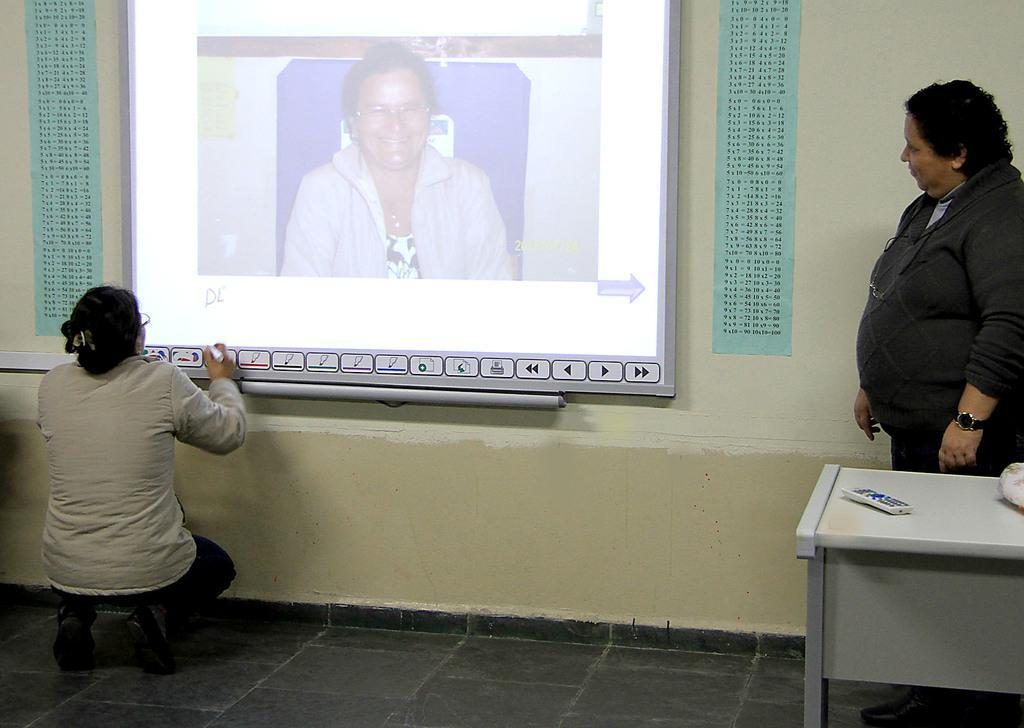Please provide a concise description of this image. In this picture we can see a person is standing on the floor and a in front of the person there is a table and on the table there is a remote control. On the left side of the person there is another person is in squat position and in front of the person there is a projector screen and a wall. 